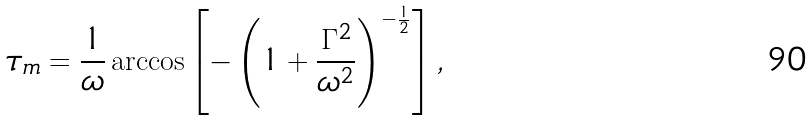<formula> <loc_0><loc_0><loc_500><loc_500>\tau _ { m } = \frac { 1 } { \omega } \arccos \left [ - \left ( 1 + \frac { \Gamma ^ { 2 } } { \omega ^ { 2 } } \right ) ^ { - \frac { 1 } { 2 } } \right ] ,</formula> 